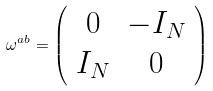Convert formula to latex. <formula><loc_0><loc_0><loc_500><loc_500>\omega ^ { a b } = \left ( \begin{array} { c c } 0 & - I _ { N } \\ I _ { N } & 0 \end{array} \right )</formula> 